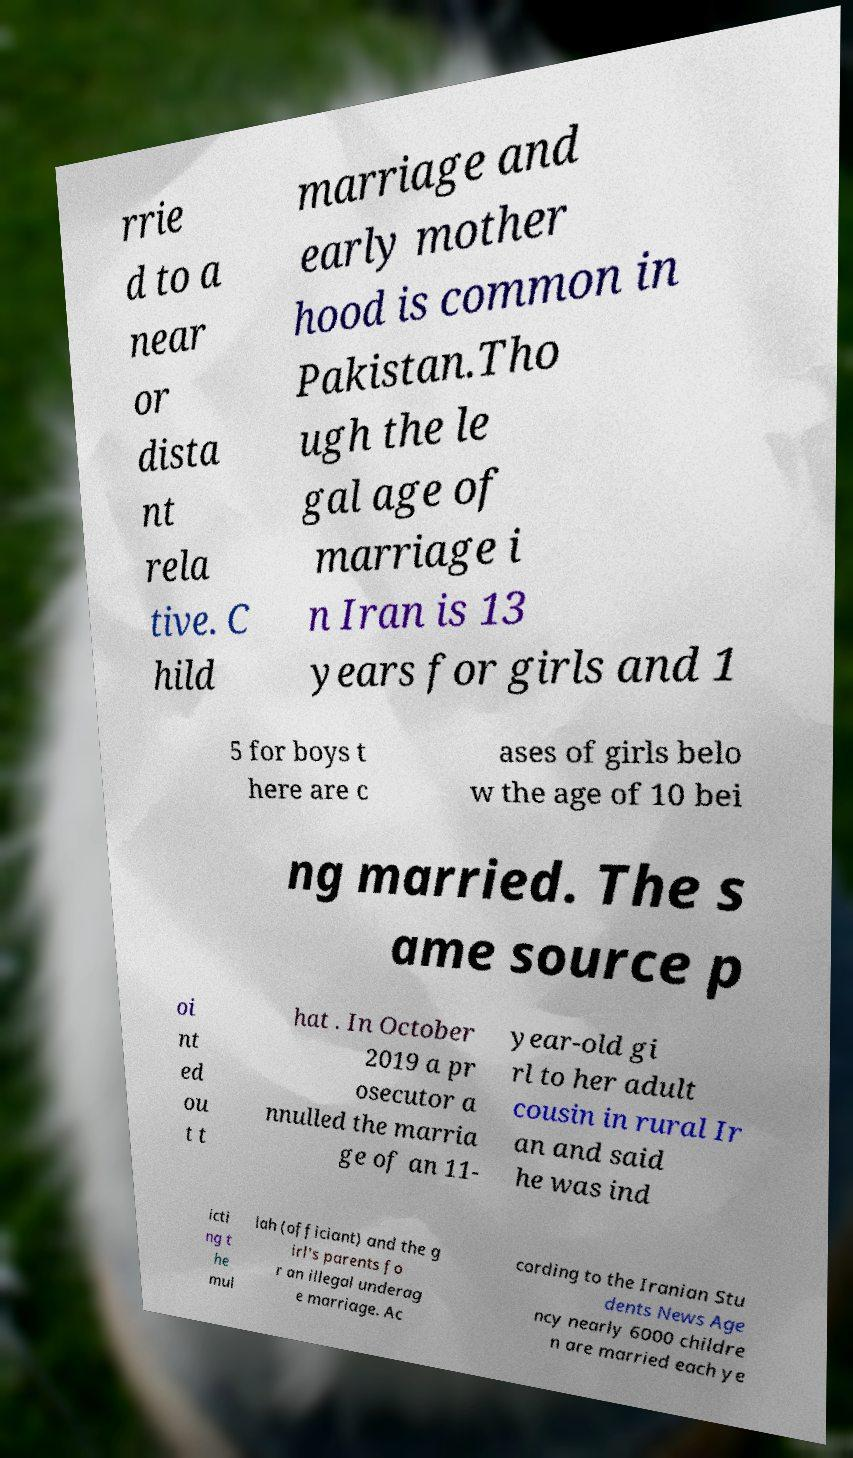Could you assist in decoding the text presented in this image and type it out clearly? rrie d to a near or dista nt rela tive. C hild marriage and early mother hood is common in Pakistan.Tho ugh the le gal age of marriage i n Iran is 13 years for girls and 1 5 for boys t here are c ases of girls belo w the age of 10 bei ng married. The s ame source p oi nt ed ou t t hat . In October 2019 a pr osecutor a nnulled the marria ge of an 11- year-old gi rl to her adult cousin in rural Ir an and said he was ind icti ng t he mul lah (officiant) and the g irl's parents fo r an illegal underag e marriage. Ac cording to the Iranian Stu dents News Age ncy nearly 6000 childre n are married each ye 